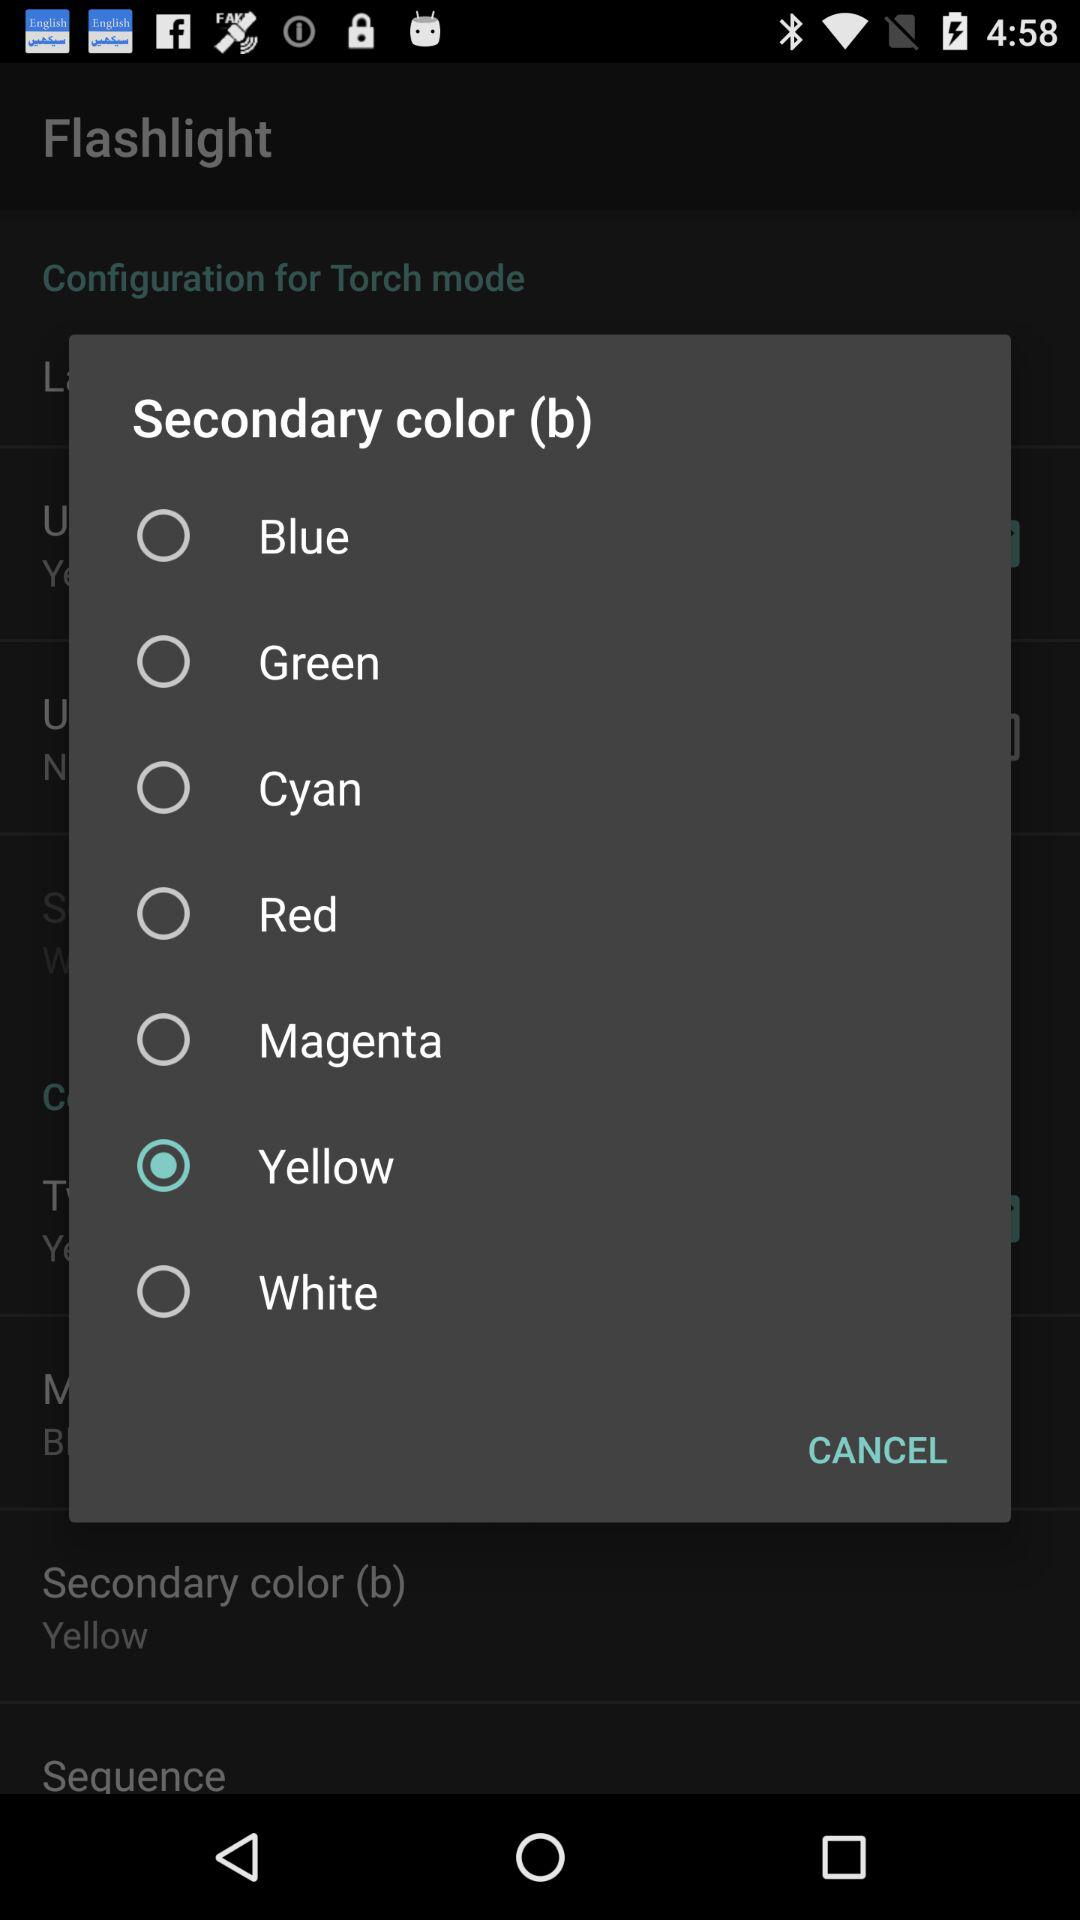What is the name of the application? The application name is "Flashlight". 